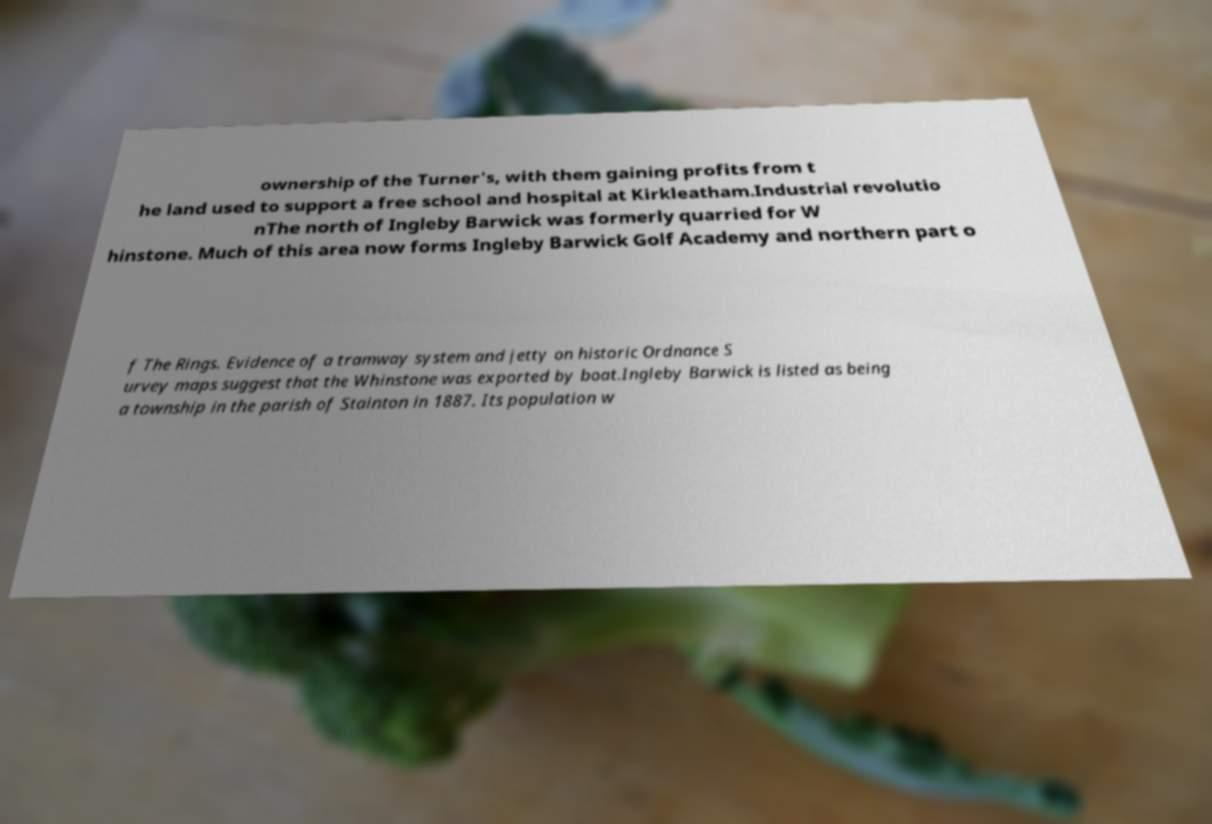For documentation purposes, I need the text within this image transcribed. Could you provide that? ownership of the Turner's, with them gaining profits from t he land used to support a free school and hospital at Kirkleatham.Industrial revolutio nThe north of Ingleby Barwick was formerly quarried for W hinstone. Much of this area now forms Ingleby Barwick Golf Academy and northern part o f The Rings. Evidence of a tramway system and jetty on historic Ordnance S urvey maps suggest that the Whinstone was exported by boat.Ingleby Barwick is listed as being a township in the parish of Stainton in 1887. Its population w 